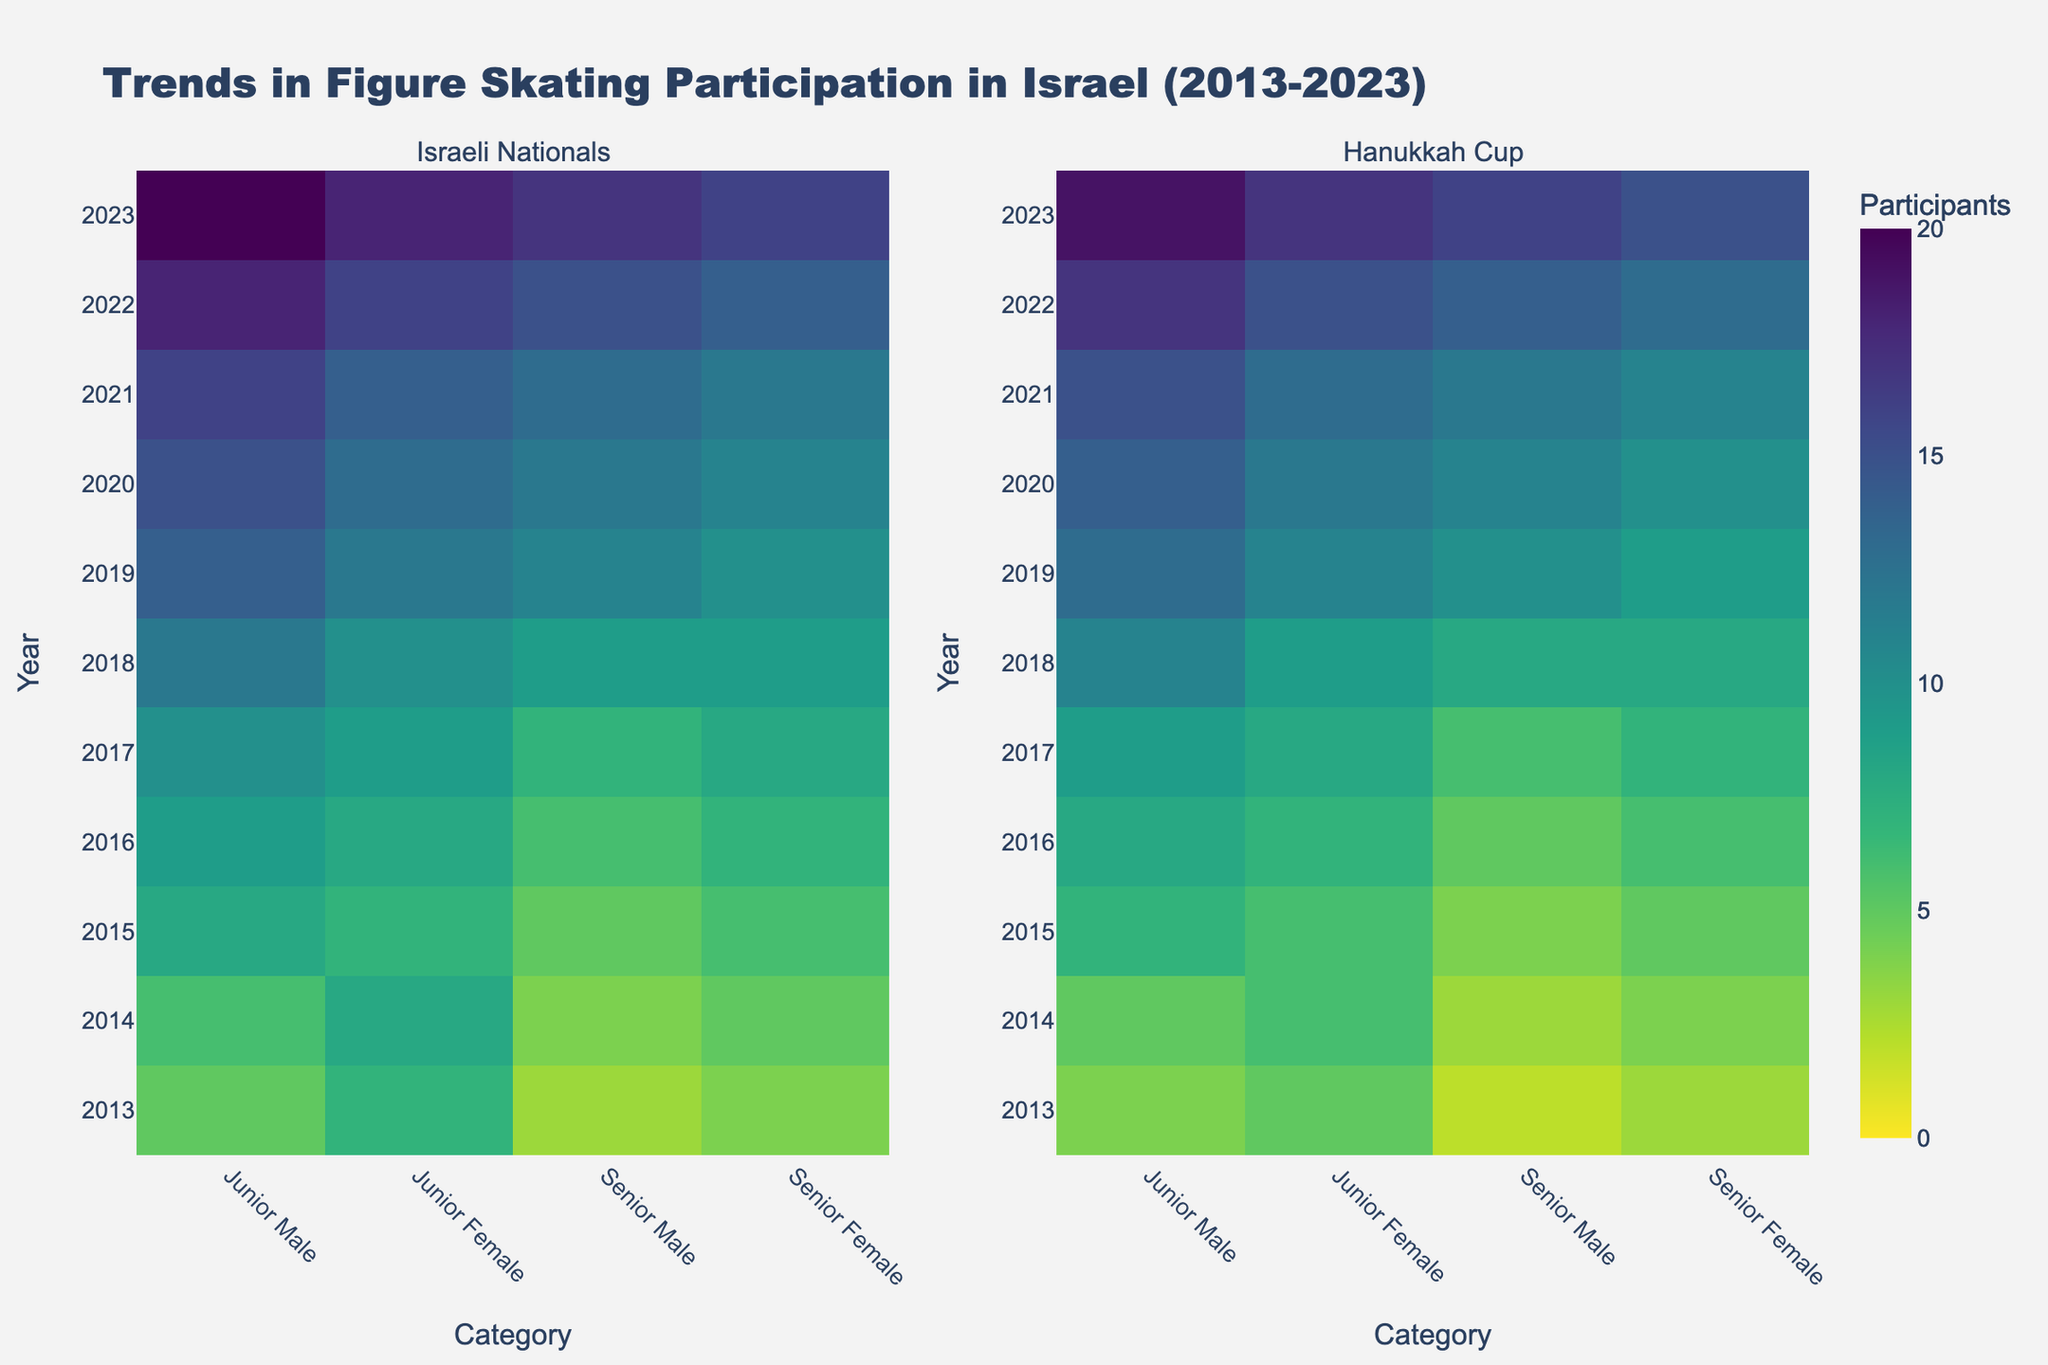What's the title of the figure? The title is prominently displayed at the top of the figure.
Answer: Trends in Figure Skating Participation in Israel (2013-2023) Which year had the highest number of Junior Male participants in the Israeli Nationals? Locate the column for Junior Male under the Israeli Nationals subplot and find the highest value along the y-axis.
Answer: 2023 How does the participation of Senior Female skaters in the Hanukkah Cup in 2020 compare to 2016? Locate the Senior Female row in the Hanukkah Cup subplot and compare the participation numbers for the years 2020 and 2016.
Answer: 11 in 2020, 6 in 2016 What is the general trend in participation for Junior Female skaters in both events over the years? Observe the Junior Female column across both subplots over the years. Compare values from 2013 to 2023.
Answer: Increasing How many Junior Male participants were there in total across both events in 2019? Sum the number of Junior Male participants in both the Israeli Nationals and Hanukkah Cup for 2019.
Answer: 27 In which year did the Israeli Nationals have the same number of participants for Junior Female and Senior Male categories? Find the years in the Israeli Nationals subplot where the values for Junior Female and Senior Male are equal.
Answer: 2015 Which category experienced the smallest overall participation growth from 2013 to 2023 in the Hanukkah Cup? Calculate the difference in participation from 2013 to 2023 for each category in the Hanukkah Cup subplot. The category with the smallest difference is the answer.
Answer: Junior Female: 7 - 5 = 2 Between 2018 and 2020, how did the number of Senior Male participants in the Israeli Nationals change? Identify the values for Senior Male in the Israeli Nationals subplot for 2018 and 2020 and compute the difference.
Answer: From 9 to 12 Which event had more consistent participation rates for Senior Female skaters over the decade? Compare the variability of the participation rates for Senior Female skaters across the years between the two events.
Answer: Israeli Nationals In what year did both events have the same number of Junior Female participants? Find the year where the number of Junior Female participants is equal in both Israeli Nationals and Hanukkah Cup subplots.
Answer: 2015 